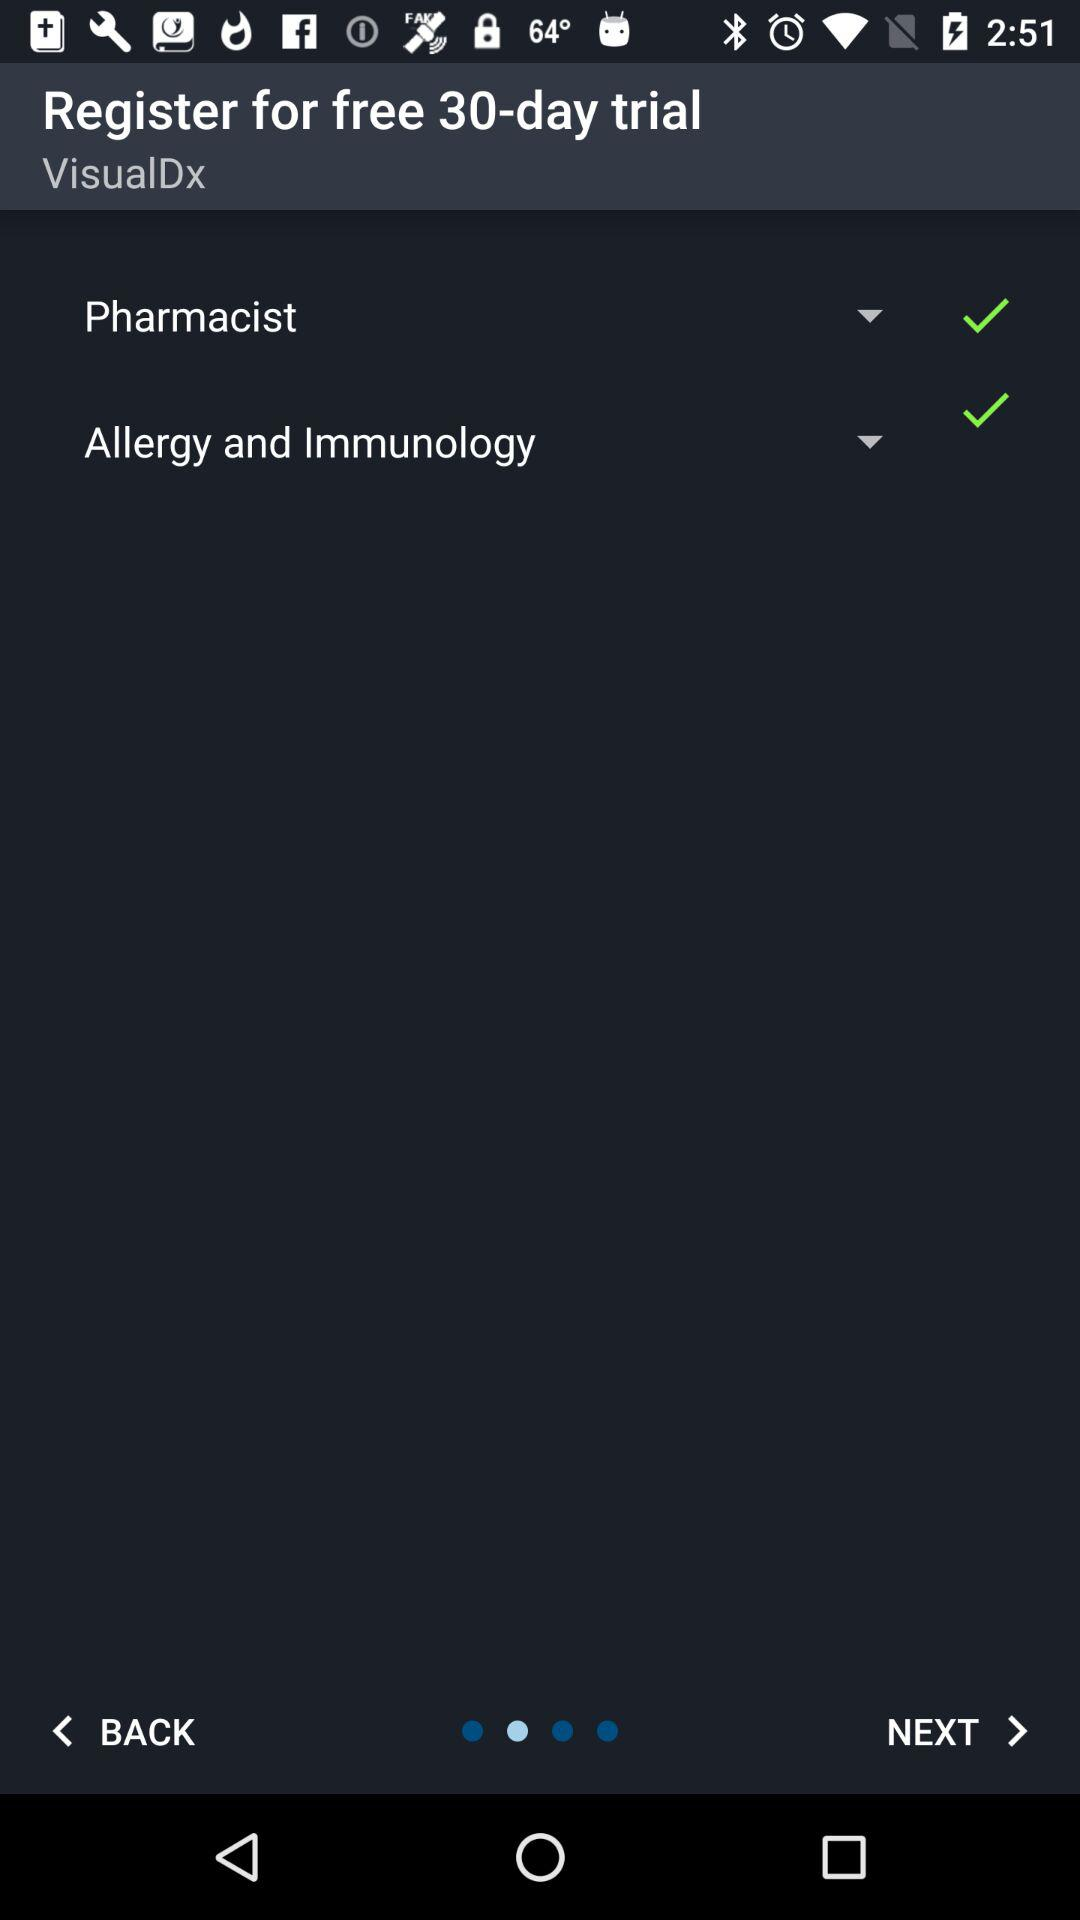What is the application name? The application name is "VisualDx". 